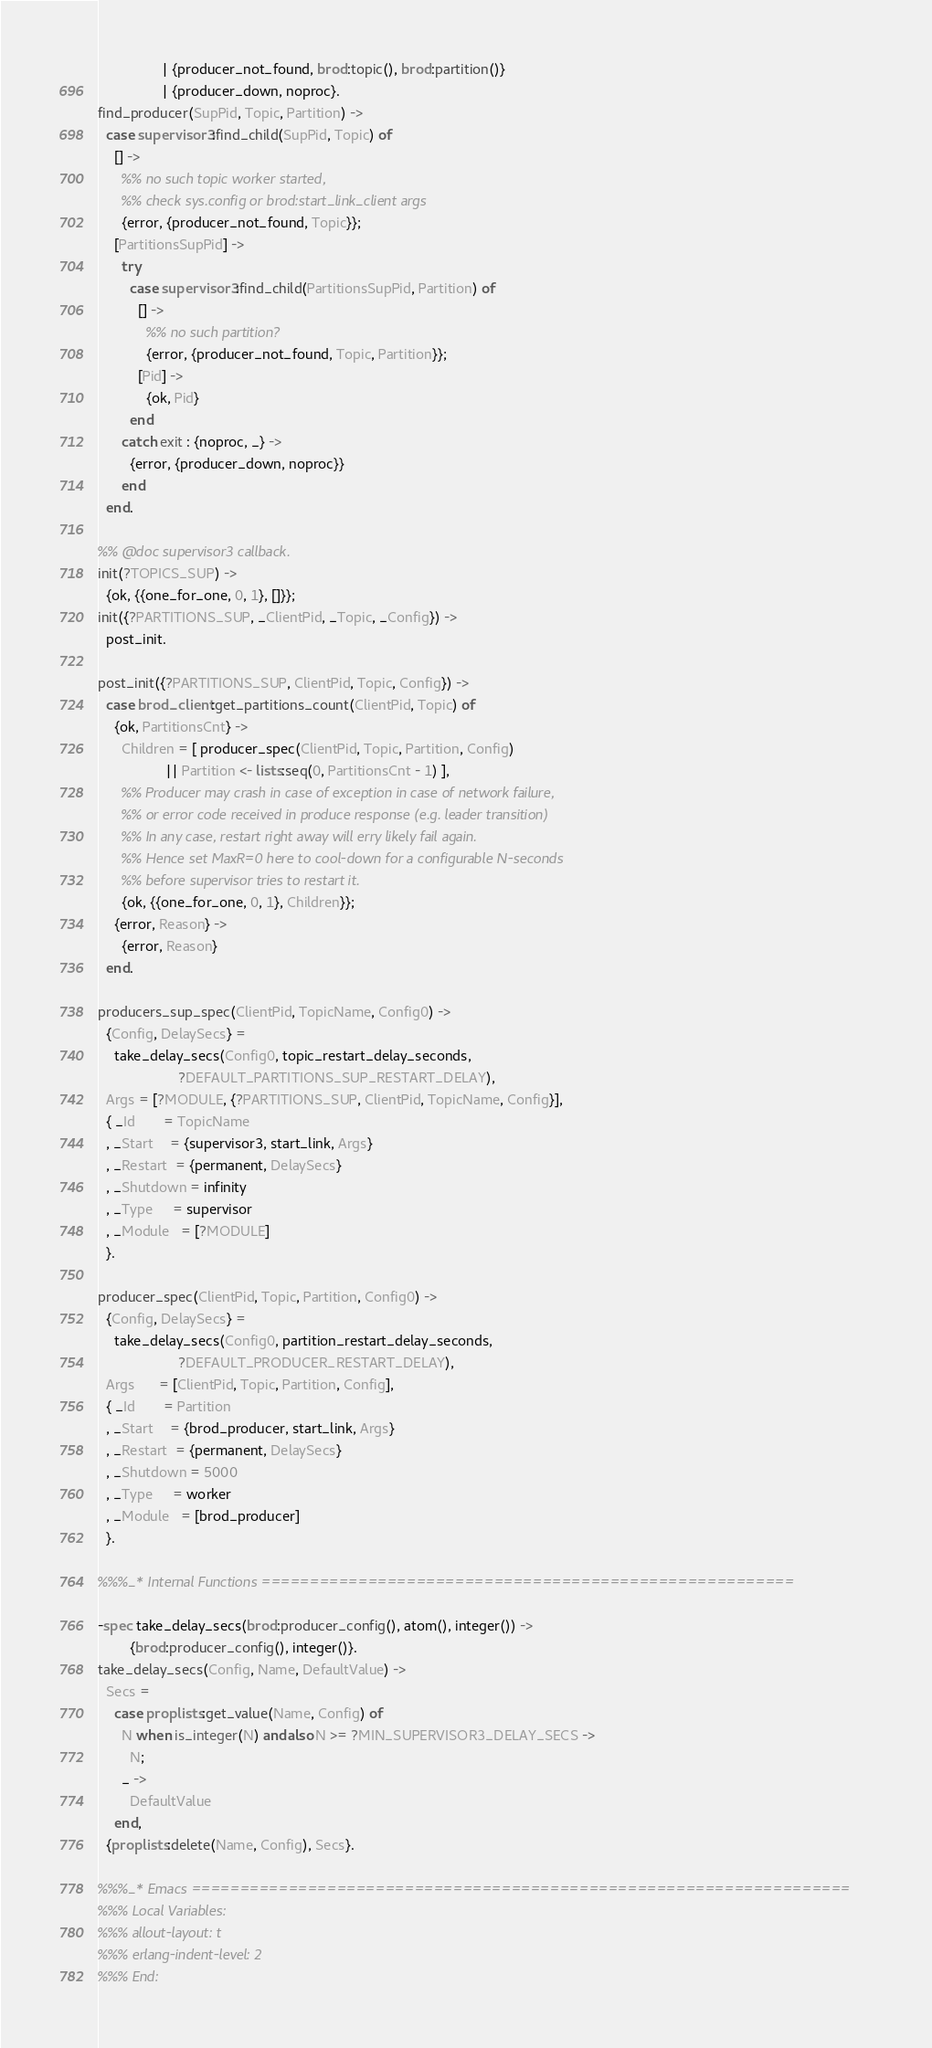<code> <loc_0><loc_0><loc_500><loc_500><_Erlang_>                | {producer_not_found, brod:topic(), brod:partition()}
                | {producer_down, noproc}.
find_producer(SupPid, Topic, Partition) ->
  case supervisor3:find_child(SupPid, Topic) of
    [] ->
      %% no such topic worker started,
      %% check sys.config or brod:start_link_client args
      {error, {producer_not_found, Topic}};
    [PartitionsSupPid] ->
      try
        case supervisor3:find_child(PartitionsSupPid, Partition) of
          [] ->
            %% no such partition?
            {error, {producer_not_found, Topic, Partition}};
          [Pid] ->
            {ok, Pid}
        end
      catch exit : {noproc, _} ->
        {error, {producer_down, noproc}}
      end
  end.

%% @doc supervisor3 callback.
init(?TOPICS_SUP) ->
  {ok, {{one_for_one, 0, 1}, []}};
init({?PARTITIONS_SUP, _ClientPid, _Topic, _Config}) ->
  post_init.

post_init({?PARTITIONS_SUP, ClientPid, Topic, Config}) ->
  case brod_client:get_partitions_count(ClientPid, Topic) of
    {ok, PartitionsCnt} ->
      Children = [ producer_spec(ClientPid, Topic, Partition, Config)
                 || Partition <- lists:seq(0, PartitionsCnt - 1) ],
      %% Producer may crash in case of exception in case of network failure,
      %% or error code received in produce response (e.g. leader transition)
      %% In any case, restart right away will erry likely fail again.
      %% Hence set MaxR=0 here to cool-down for a configurable N-seconds
      %% before supervisor tries to restart it.
      {ok, {{one_for_one, 0, 1}, Children}};
    {error, Reason} ->
      {error, Reason}
  end.

producers_sup_spec(ClientPid, TopicName, Config0) ->
  {Config, DelaySecs} =
    take_delay_secs(Config0, topic_restart_delay_seconds,
                    ?DEFAULT_PARTITIONS_SUP_RESTART_DELAY),
  Args = [?MODULE, {?PARTITIONS_SUP, ClientPid, TopicName, Config}],
  { _Id       = TopicName
  , _Start    = {supervisor3, start_link, Args}
  , _Restart  = {permanent, DelaySecs}
  , _Shutdown = infinity
  , _Type     = supervisor
  , _Module   = [?MODULE]
  }.

producer_spec(ClientPid, Topic, Partition, Config0) ->
  {Config, DelaySecs} =
    take_delay_secs(Config0, partition_restart_delay_seconds,
                    ?DEFAULT_PRODUCER_RESTART_DELAY),
  Args      = [ClientPid, Topic, Partition, Config],
  { _Id       = Partition
  , _Start    = {brod_producer, start_link, Args}
  , _Restart  = {permanent, DelaySecs}
  , _Shutdown = 5000
  , _Type     = worker
  , _Module   = [brod_producer]
  }.

%%%_* Internal Functions =======================================================

-spec take_delay_secs(brod:producer_config(), atom(), integer()) ->
        {brod:producer_config(), integer()}.
take_delay_secs(Config, Name, DefaultValue) ->
  Secs =
    case proplists:get_value(Name, Config) of
      N when is_integer(N) andalso N >= ?MIN_SUPERVISOR3_DELAY_SECS ->
        N;
      _ ->
        DefaultValue
    end,
  {proplists:delete(Name, Config), Secs}.

%%%_* Emacs ====================================================================
%%% Local Variables:
%%% allout-layout: t
%%% erlang-indent-level: 2
%%% End:
</code> 